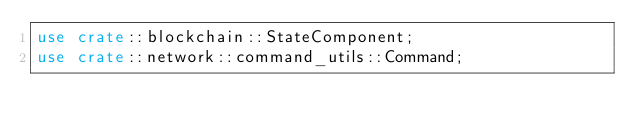Convert code to text. <code><loc_0><loc_0><loc_500><loc_500><_Rust_>use crate::blockchain::StateComponent;
use crate::network::command_utils::Command;</code> 